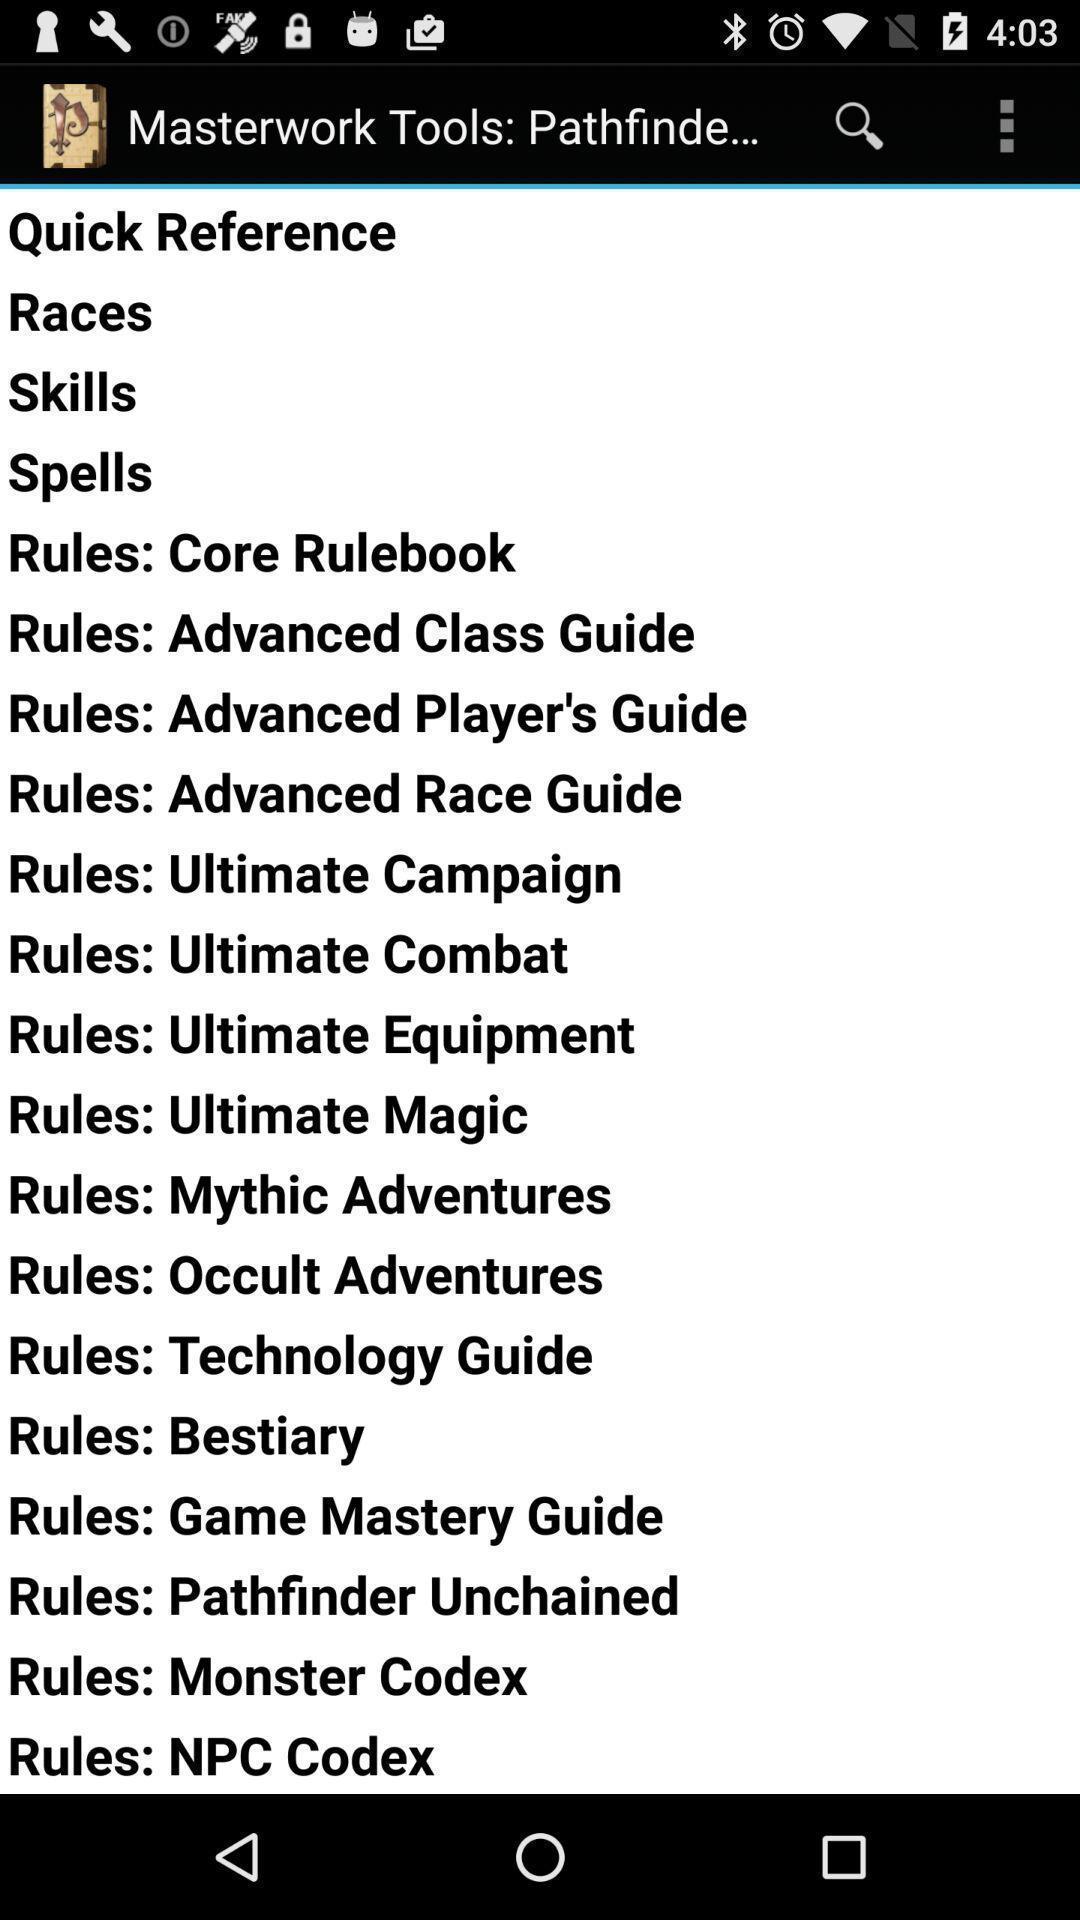Describe the key features of this screenshot. Screen shows about master work tools. 